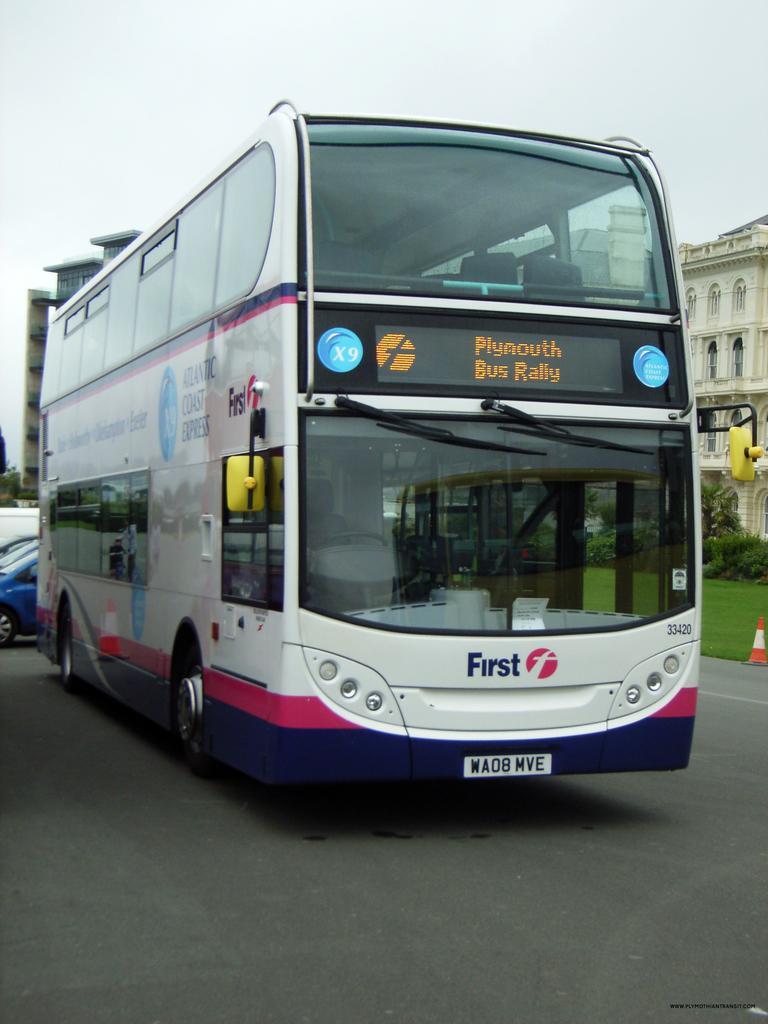Can you describe this image briefly? This image is clicked on the road. In the foreground there is a bus on the road. Behind the bus there are vehicles. To the right there is a cone barrier on the road. Behind the cone barrier there are plants and grass on the ground. In the background there are buildings. At the top there is the sky. 